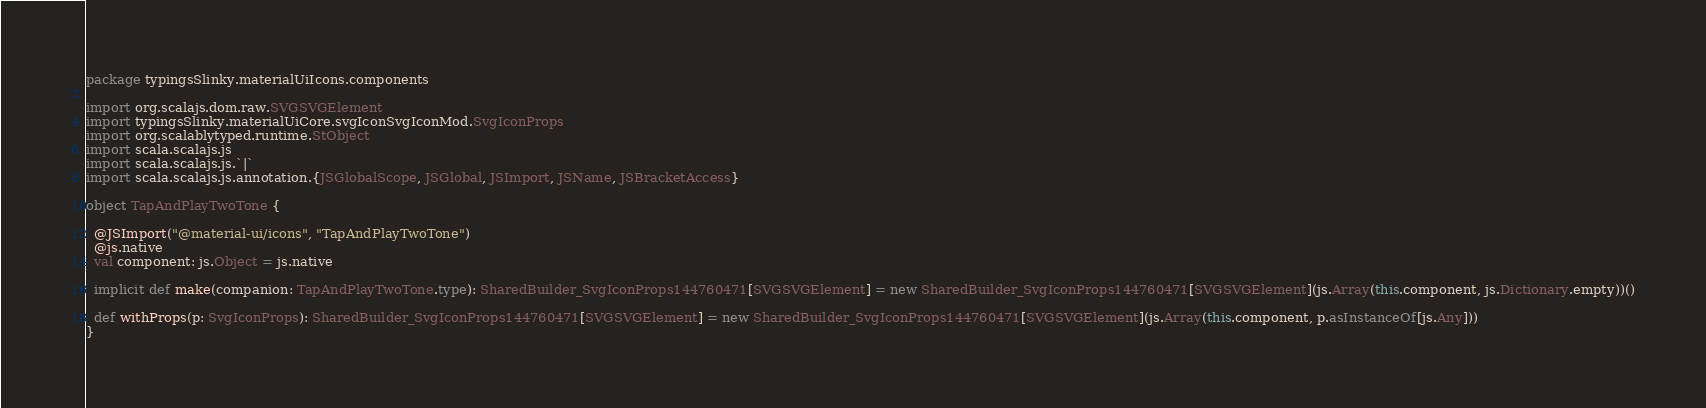<code> <loc_0><loc_0><loc_500><loc_500><_Scala_>package typingsSlinky.materialUiIcons.components

import org.scalajs.dom.raw.SVGSVGElement
import typingsSlinky.materialUiCore.svgIconSvgIconMod.SvgIconProps
import org.scalablytyped.runtime.StObject
import scala.scalajs.js
import scala.scalajs.js.`|`
import scala.scalajs.js.annotation.{JSGlobalScope, JSGlobal, JSImport, JSName, JSBracketAccess}

object TapAndPlayTwoTone {
  
  @JSImport("@material-ui/icons", "TapAndPlayTwoTone")
  @js.native
  val component: js.Object = js.native
  
  implicit def make(companion: TapAndPlayTwoTone.type): SharedBuilder_SvgIconProps144760471[SVGSVGElement] = new SharedBuilder_SvgIconProps144760471[SVGSVGElement](js.Array(this.component, js.Dictionary.empty))()
  
  def withProps(p: SvgIconProps): SharedBuilder_SvgIconProps144760471[SVGSVGElement] = new SharedBuilder_SvgIconProps144760471[SVGSVGElement](js.Array(this.component, p.asInstanceOf[js.Any]))
}
</code> 